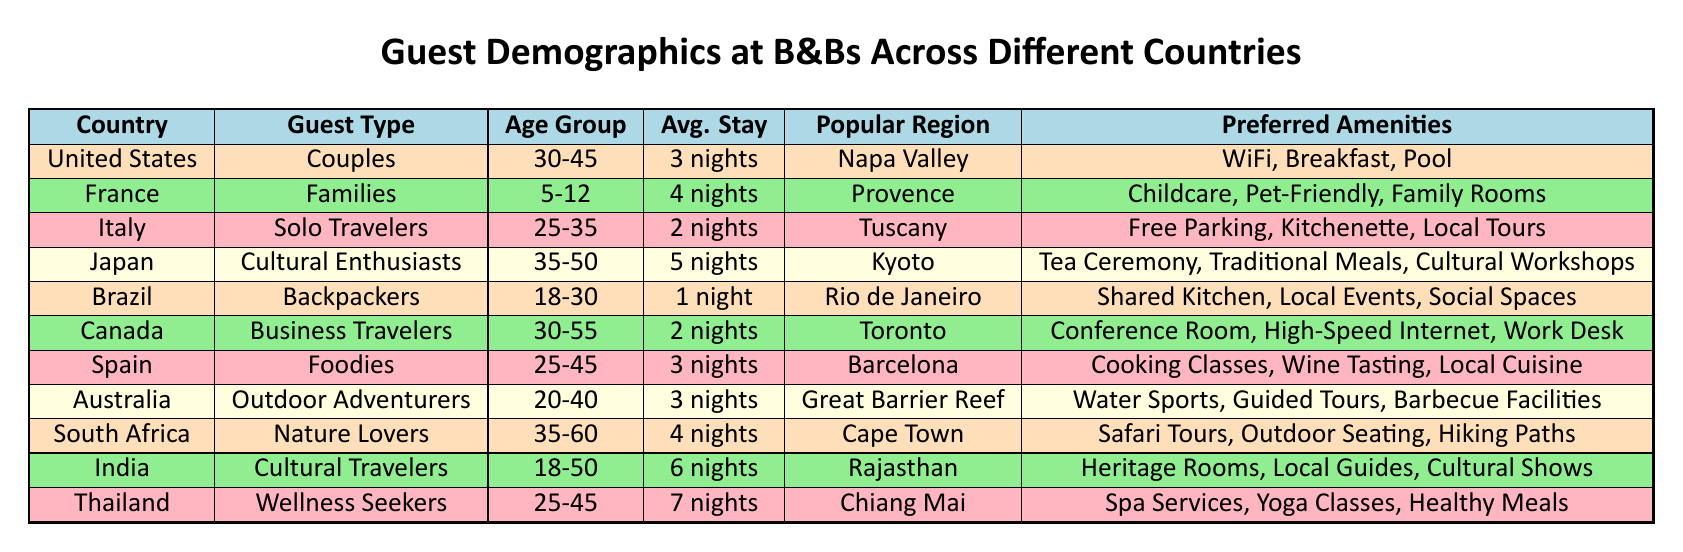What is the average stay for guests in Italy? From the table, for Italy, the average stay for Solo Travelers is noted as "2 nights." This data point is retrieved directly from the corresponding row in the table.
Answer: 2 nights Which country has the most extended average stay according to the table? Upon reviewing the table, we see that Thailand (Wellness Seekers) has the longest average stay of "7 nights." We compare this duration against others, which are lower, confirming that Thailand holds the longest duration.
Answer: Thailand Are there any guest types in Japan who prefer a common amenity, such as WiFi? Looking at the table, Japan features "Cultural Enthusiasts" who desire amenities like "Tea Ceremony" and "Traditional Meals," but does not list WiFi as a preferred amenity. Since no guest type in Japan lists WiFi, the answer is no.
Answer: No What is the cumulative average stay for Nature Lovers in South Africa and Cultural Travelers in India? We examine the average stays: Nature Lovers (South Africa) have "4 nights," and Cultural Travelers (India) have "6 nights." Adding these together gives 4 + 6 = 10 nights, representing the cumulative average stay for these two groups.
Answer: 10 nights In which region is the most popular guest type of Couples found, and what are their preferred amenities? The table indicates that Couples are most popular in the United States, particularly in Napa Valley. Their preferred amenities include "WiFi," "Breakfast," and "Pool," thus answering both aspects of the question by summarizing relevant data.
Answer: Napa Valley, WiFi, Breakfast, Pool How many guest types prefer amenities that involve cooking-related activities? The table identifies two guest types that prefer cooking-related amenities: the Foodies in Spain desire "Cooking Classes" and "Wine Tasting." Counting these shows that there are 2 distinct guest types engaged in cooking activities.
Answer: 2 What is the age range for Cultural Travelers in India? The table clearly describes the age group for Cultural Travelers in India as "18-50." This information is directly taken from the row associated with India in the table.
Answer: 18-50 Does the data indicate that all solo travelers have a shorter average stay compared to families? By reviewing the table, we find that Solo Travelers in Italy have an average stay of "2 nights," while Families in France have an average stay of "4 nights." Since "2" is less than "4," we conclude that not all solo travelers have a shorter stay compared to families in this instance, but some do.
Answer: No Which country has the highest average age group for its guests, and what is that age group? Analyzing the age groups, the respective ages for guests in South Africa (Nature Lovers) is "35-60," which spans a higher range compared to any other country. Thus, South Africa has the highest average age group for its guests at "35-60."
Answer: South Africa, 35-60 